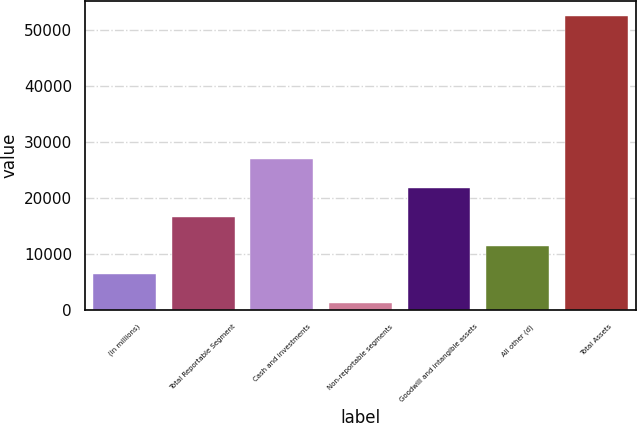Convert chart. <chart><loc_0><loc_0><loc_500><loc_500><bar_chart><fcel>(in millions)<fcel>Total Reportable Segment<fcel>Cash and investments<fcel>Non-reportable segments<fcel>Goodwill and intangible assets<fcel>All other (d)<fcel>Total Assets<nl><fcel>6418.6<fcel>16695.8<fcel>26973<fcel>1280<fcel>21834.4<fcel>11557.2<fcel>52666<nl></chart> 